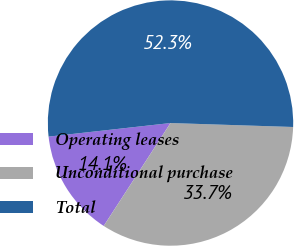Convert chart to OTSL. <chart><loc_0><loc_0><loc_500><loc_500><pie_chart><fcel>Operating leases<fcel>Unconditional purchase<fcel>Total<nl><fcel>14.07%<fcel>33.65%<fcel>52.28%<nl></chart> 